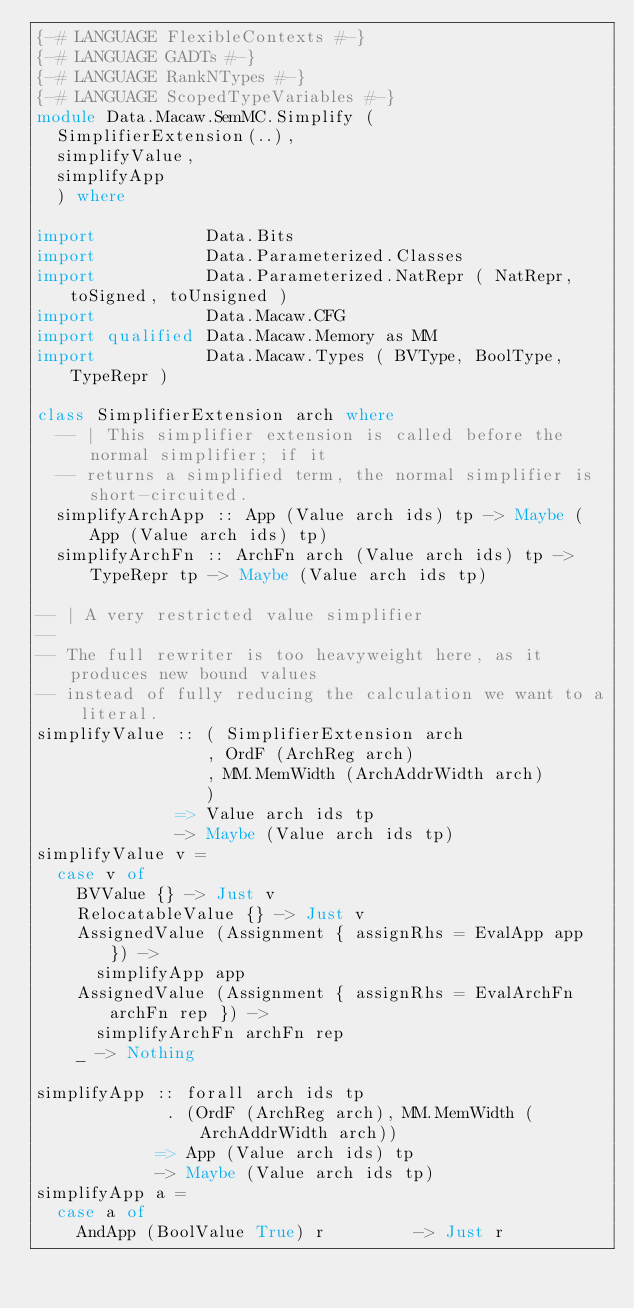Convert code to text. <code><loc_0><loc_0><loc_500><loc_500><_Haskell_>{-# LANGUAGE FlexibleContexts #-}
{-# LANGUAGE GADTs #-}
{-# LANGUAGE RankNTypes #-}
{-# LANGUAGE ScopedTypeVariables #-}
module Data.Macaw.SemMC.Simplify (
  SimplifierExtension(..),
  simplifyValue,
  simplifyApp
  ) where

import           Data.Bits
import           Data.Parameterized.Classes
import           Data.Parameterized.NatRepr ( NatRepr, toSigned, toUnsigned )
import           Data.Macaw.CFG
import qualified Data.Macaw.Memory as MM
import           Data.Macaw.Types ( BVType, BoolType, TypeRepr )

class SimplifierExtension arch where
  -- | This simplifier extension is called before the normal simplifier; if it
  -- returns a simplified term, the normal simplifier is short-circuited.
  simplifyArchApp :: App (Value arch ids) tp -> Maybe (App (Value arch ids) tp)
  simplifyArchFn :: ArchFn arch (Value arch ids) tp -> TypeRepr tp -> Maybe (Value arch ids tp)

-- | A very restricted value simplifier
--
-- The full rewriter is too heavyweight here, as it produces new bound values
-- instead of fully reducing the calculation we want to a literal.
simplifyValue :: ( SimplifierExtension arch
                 , OrdF (ArchReg arch)
                 , MM.MemWidth (ArchAddrWidth arch)
                 )
              => Value arch ids tp
              -> Maybe (Value arch ids tp)
simplifyValue v =
  case v of
    BVValue {} -> Just v
    RelocatableValue {} -> Just v
    AssignedValue (Assignment { assignRhs = EvalApp app }) ->
      simplifyApp app
    AssignedValue (Assignment { assignRhs = EvalArchFn archFn rep }) ->
      simplifyArchFn archFn rep
    _ -> Nothing

simplifyApp :: forall arch ids tp
             . (OrdF (ArchReg arch), MM.MemWidth (ArchAddrWidth arch))
            => App (Value arch ids) tp
            -> Maybe (Value arch ids tp)
simplifyApp a =
  case a of
    AndApp (BoolValue True) r         -> Just r</code> 